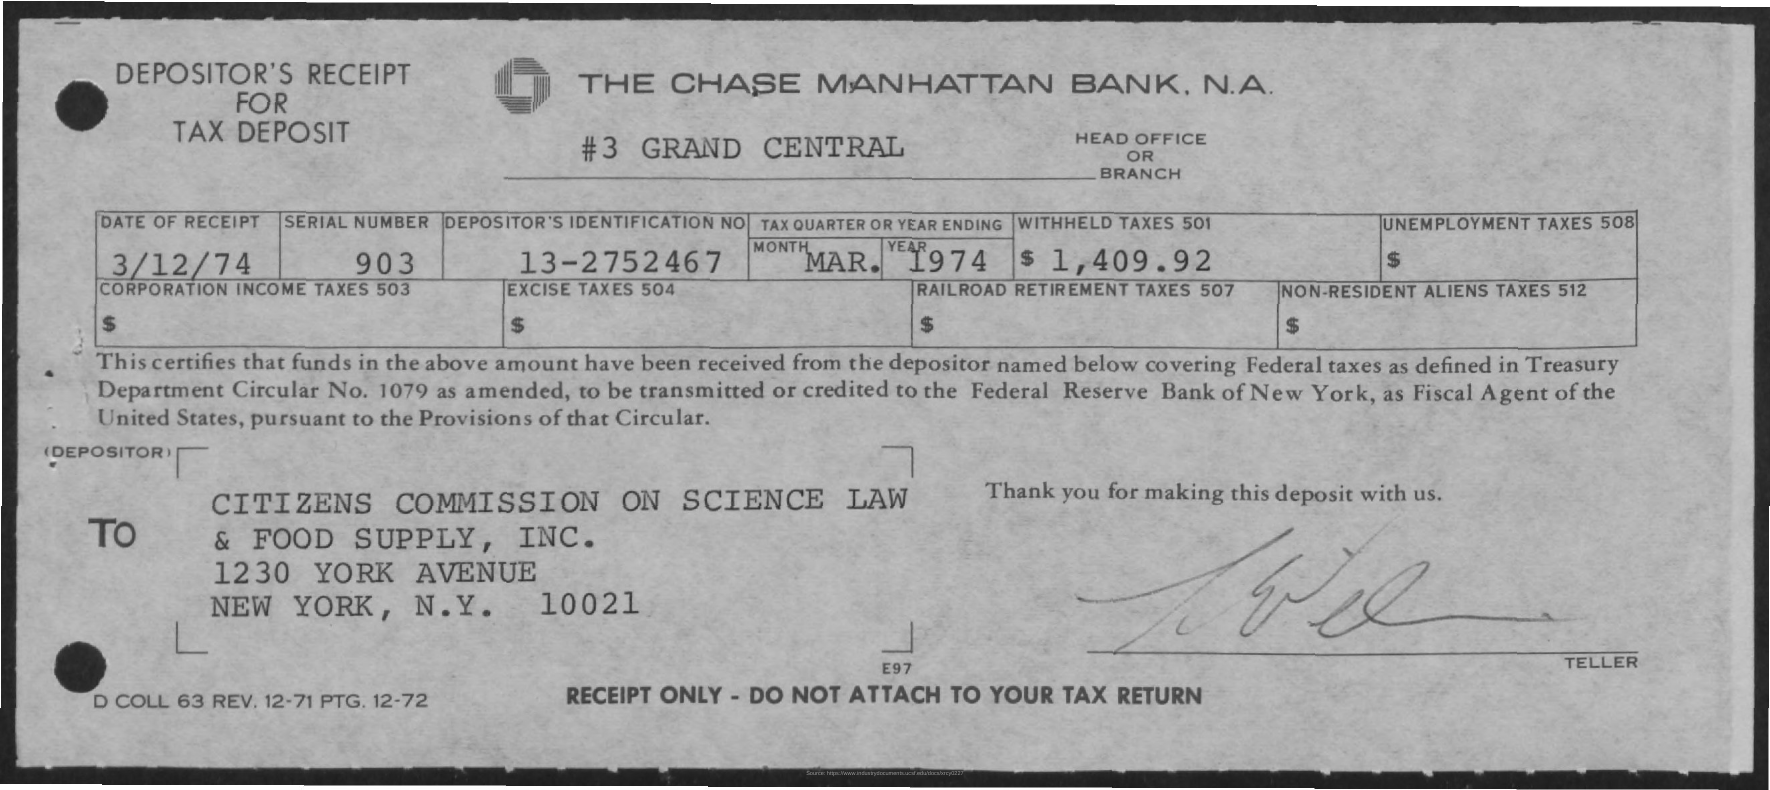Identify some key points in this picture. What is the serial number? It is 903... The location of the headquarters or branch is unknown. The date of receipt is March 12, 1974. The withheld taxes amount to $1,409.92. The name of the bank is The Chase Manhattan Bank. 